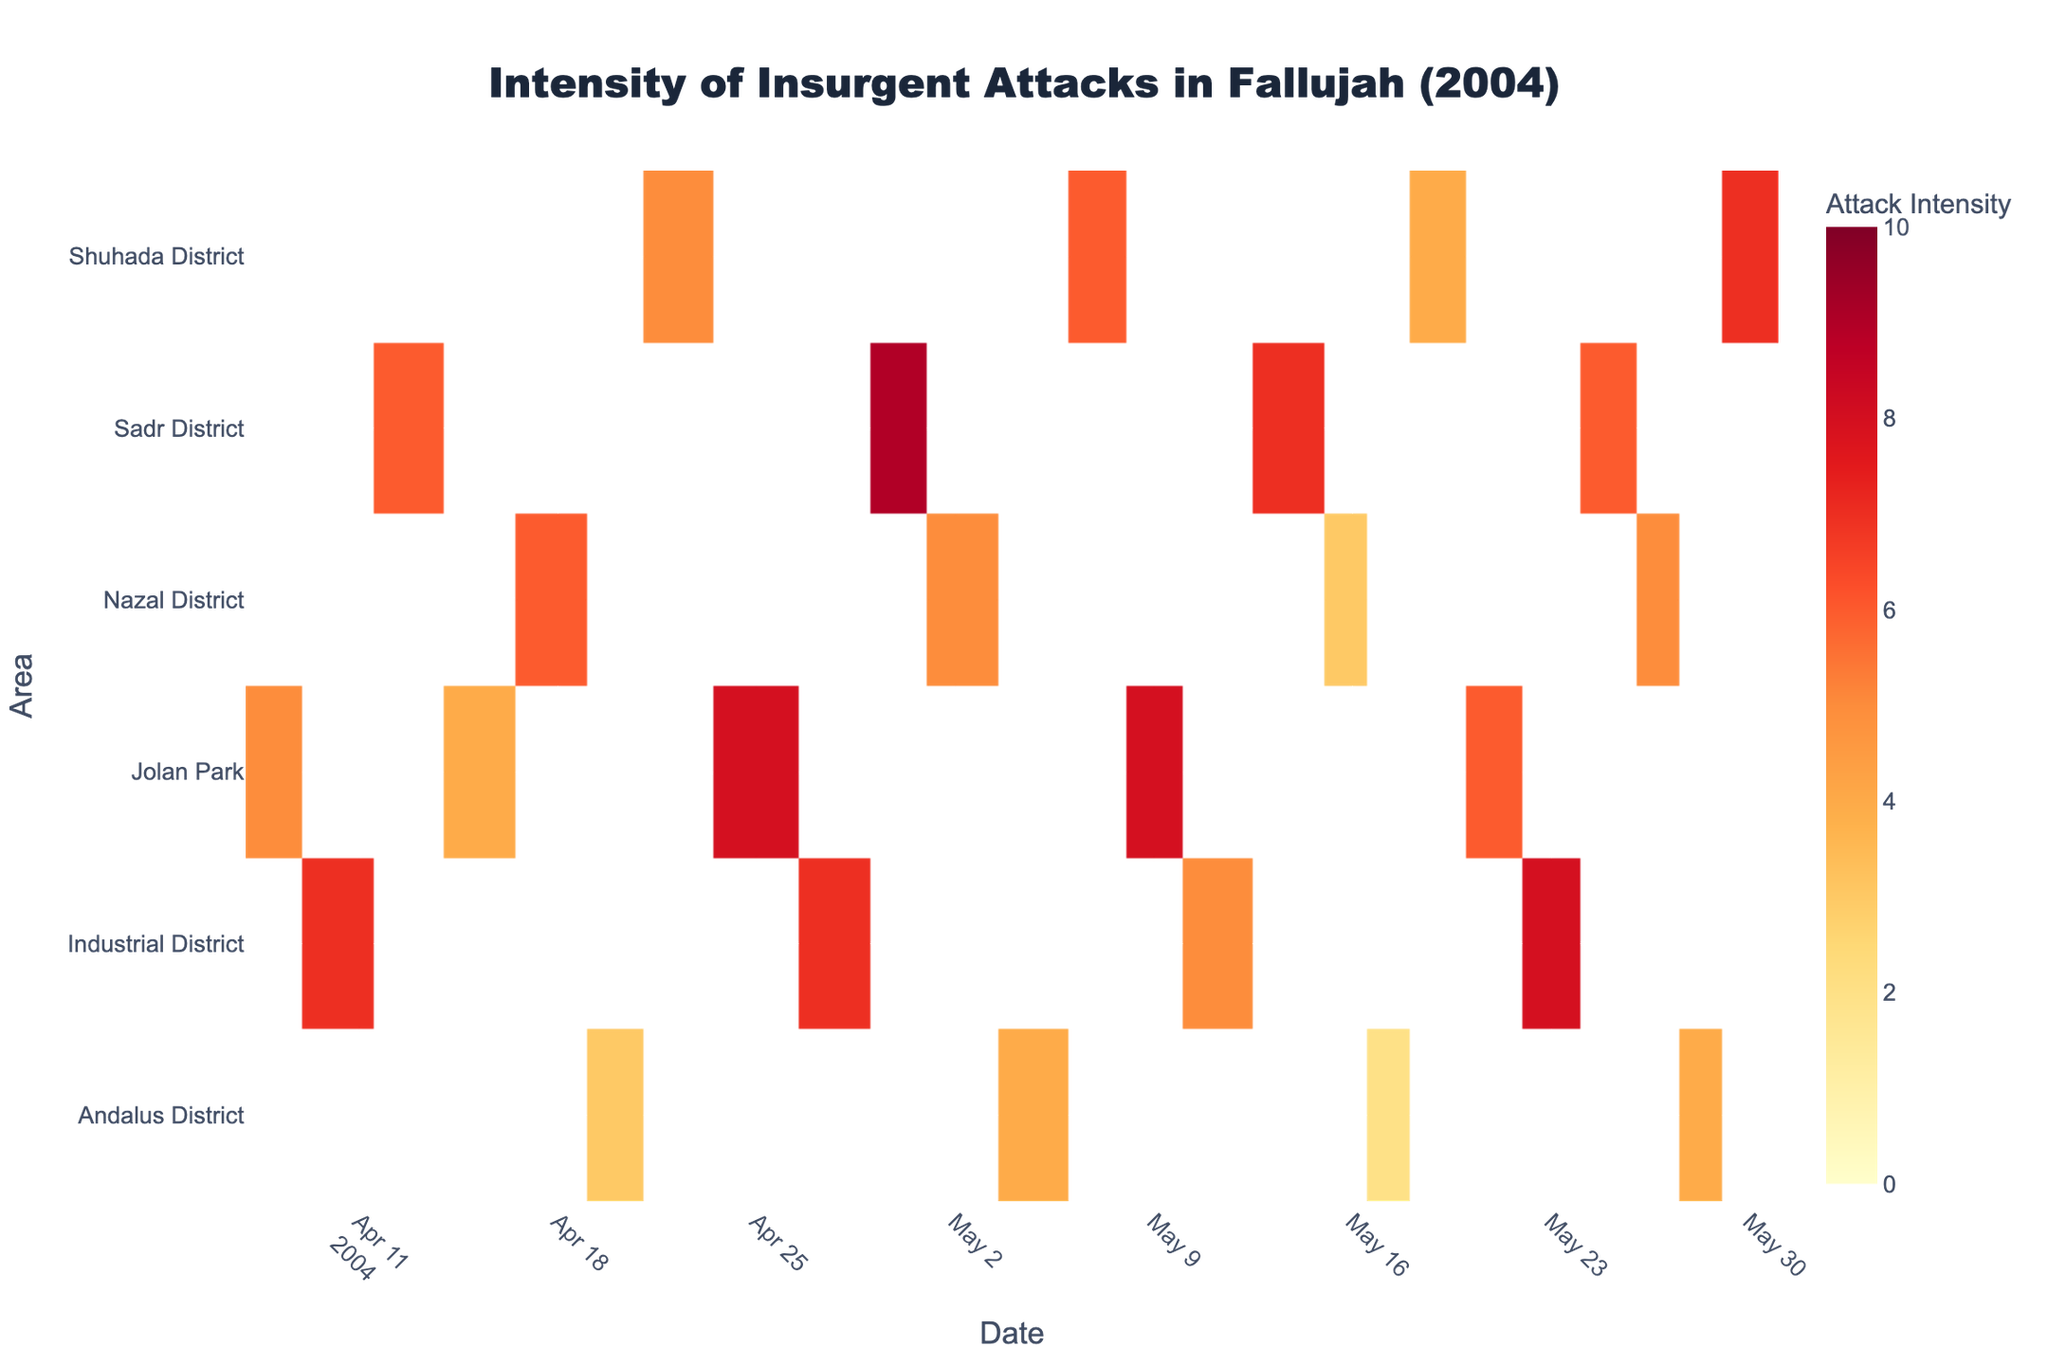What is the title of the heatmap? The title is usually displayed at the top of the figure. In this case, the title states, "Intensity of Insurgent Attacks in Fallujah (2004)" as part of the layout setup.
Answer: Intensity of Insurgent Attacks in Fallujah (2004) How many different areas are represented in the heatmap? Look at the y-axis, which lists the different areas in Fallujah. Count the unique area names: "Jolan Park," "Industrial District," "Sadr District," "Nazal District," "Andalus District," and "Shuhada District."
Answer: 6 Which area experienced the highest intensity attack on April 30, 2004? Check the intersection of the y-axis entry for each area with the x-axis entry for April 30, 2004. The Sadr District shows the highest value in this intersection.
Answer: Sadr District How does the attack intensity on April 25, 2004 in Jolan Park compare to the attack intensity on May 9, 2004 in the same area? Find both dates on the x-axis and check the respective values in the Jolan Park row. The intensity on April 25 is 8, while on May 9 it is also 8, meaning they are equal.
Answer: Equal Which area had the lowest frequency of attacks in late April (April 20th onward)? Examine the intensity values from April 20 onward. The Andalus District shows predominantly lower intensity values: specifically, 3, 4, and 2 on April 20, May 5, and May 17, respectively.
Answer: Andalus District What is the average intensity of attacks in the Industrial District throughout the data provided? Extract the intensity values for the Industrial District: 7, 7, 5, 8, 5, 7, 5. Add them up and divide by the number of entries, which yields (7+7+5+8+5+7+5)/7 = 6.2857, approximately 6.3 when rounded.
Answer: 6.3 On which date did the Nazal District experience an attack intensity of 6? Check the values in the Nazal District row and find the date with an intensity of 6. The date corresponding to this value is April 18, 2004.
Answer: April 18, 2004 Between April and May 2004, did the intensity of attacks in the Shuhada District generally increase, decrease, or stay the same? By looking at the values in the row for the Shuhada District, the intensity values are 5, 6, 7, 4, and 7. Comparing these, it shows some fluctuations without a significant trend but largely stays within the same range indicating it stayed the same more or less.
Answer: Stayed the same Which district had the highest intensity attack in May 2004? Examining the values in May 2004 across all areas, the highest value appears in the Sadr District with a value of 9 on May 14.
Answer: Sadr District 